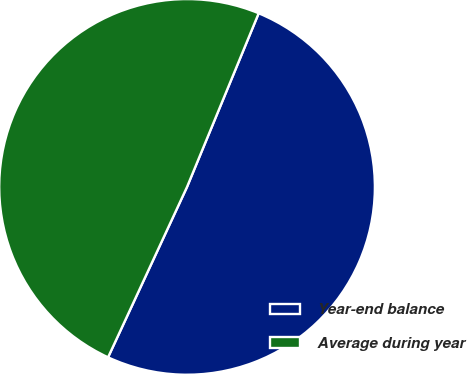Convert chart. <chart><loc_0><loc_0><loc_500><loc_500><pie_chart><fcel>Year-end balance<fcel>Average during year<nl><fcel>50.68%<fcel>49.32%<nl></chart> 